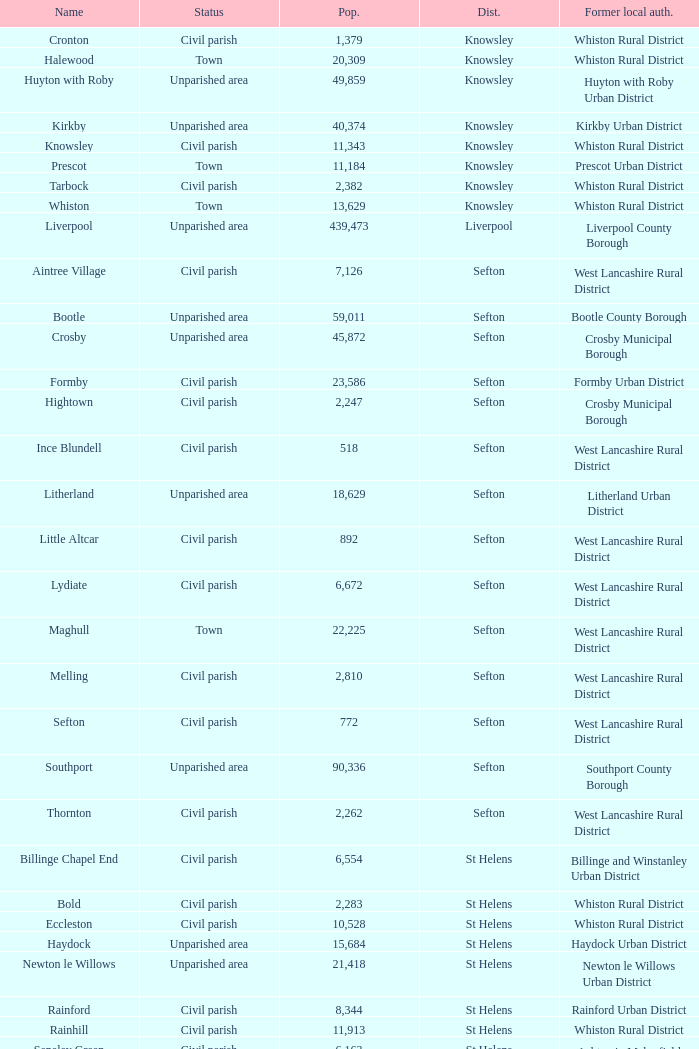What is the district of wallasey Wirral. 